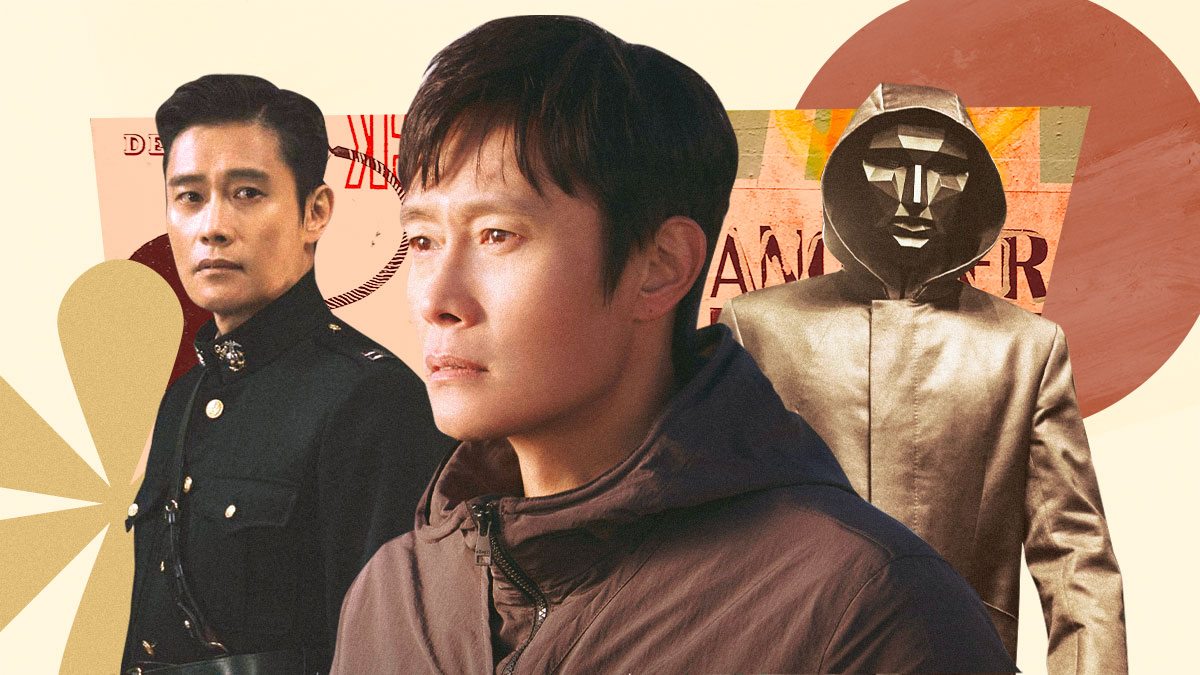What themes do you think this image is trying to convey? This image appears to be exploring themes of versatility and transformation. The three different portrayals of the actor suggest a range of emotions and roles, highlighting his ability to adapt and transform his persona. The military uniform may represent discipline and authority, the casual attire might signify everyday life or internal struggles, and the masked figure can be seen as a symbol of mystery or hidden truths. The warm and vibrant colors in the background could signify intensity and passion, adding depth to the varying narratives depicted. 